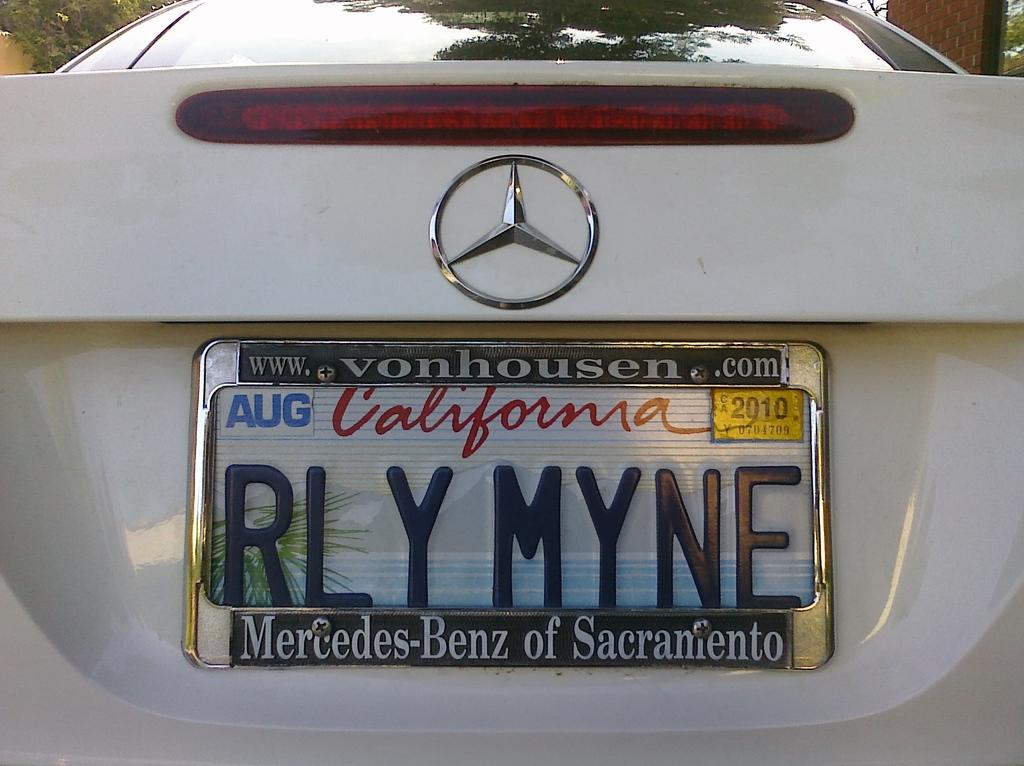What dateis n the plate?
Keep it short and to the point. Aug 2010. What state is the license plate from?
Your answer should be very brief. California. 